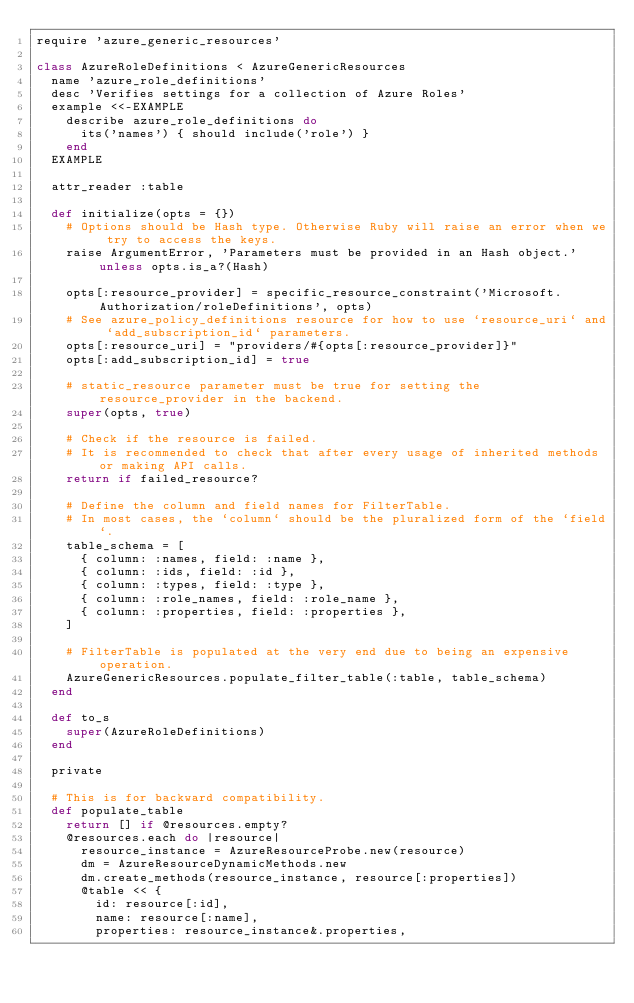<code> <loc_0><loc_0><loc_500><loc_500><_Ruby_>require 'azure_generic_resources'

class AzureRoleDefinitions < AzureGenericResources
  name 'azure_role_definitions'
  desc 'Verifies settings for a collection of Azure Roles'
  example <<-EXAMPLE
    describe azure_role_definitions do
      its('names') { should include('role') }
    end
  EXAMPLE

  attr_reader :table

  def initialize(opts = {})
    # Options should be Hash type. Otherwise Ruby will raise an error when we try to access the keys.
    raise ArgumentError, 'Parameters must be provided in an Hash object.' unless opts.is_a?(Hash)

    opts[:resource_provider] = specific_resource_constraint('Microsoft.Authorization/roleDefinitions', opts)
    # See azure_policy_definitions resource for how to use `resource_uri` and `add_subscription_id` parameters.
    opts[:resource_uri] = "providers/#{opts[:resource_provider]}"
    opts[:add_subscription_id] = true

    # static_resource parameter must be true for setting the resource_provider in the backend.
    super(opts, true)

    # Check if the resource is failed.
    # It is recommended to check that after every usage of inherited methods or making API calls.
    return if failed_resource?

    # Define the column and field names for FilterTable.
    # In most cases, the `column` should be the pluralized form of the `field`.
    table_schema = [
      { column: :names, field: :name },
      { column: :ids, field: :id },
      { column: :types, field: :type },
      { column: :role_names, field: :role_name },
      { column: :properties, field: :properties },
    ]

    # FilterTable is populated at the very end due to being an expensive operation.
    AzureGenericResources.populate_filter_table(:table, table_schema)
  end

  def to_s
    super(AzureRoleDefinitions)
  end

  private

  # This is for backward compatibility.
  def populate_table
    return [] if @resources.empty?
    @resources.each do |resource|
      resource_instance = AzureResourceProbe.new(resource)
      dm = AzureResourceDynamicMethods.new
      dm.create_methods(resource_instance, resource[:properties])
      @table << {
        id: resource[:id],
        name: resource[:name],
        properties: resource_instance&.properties,</code> 